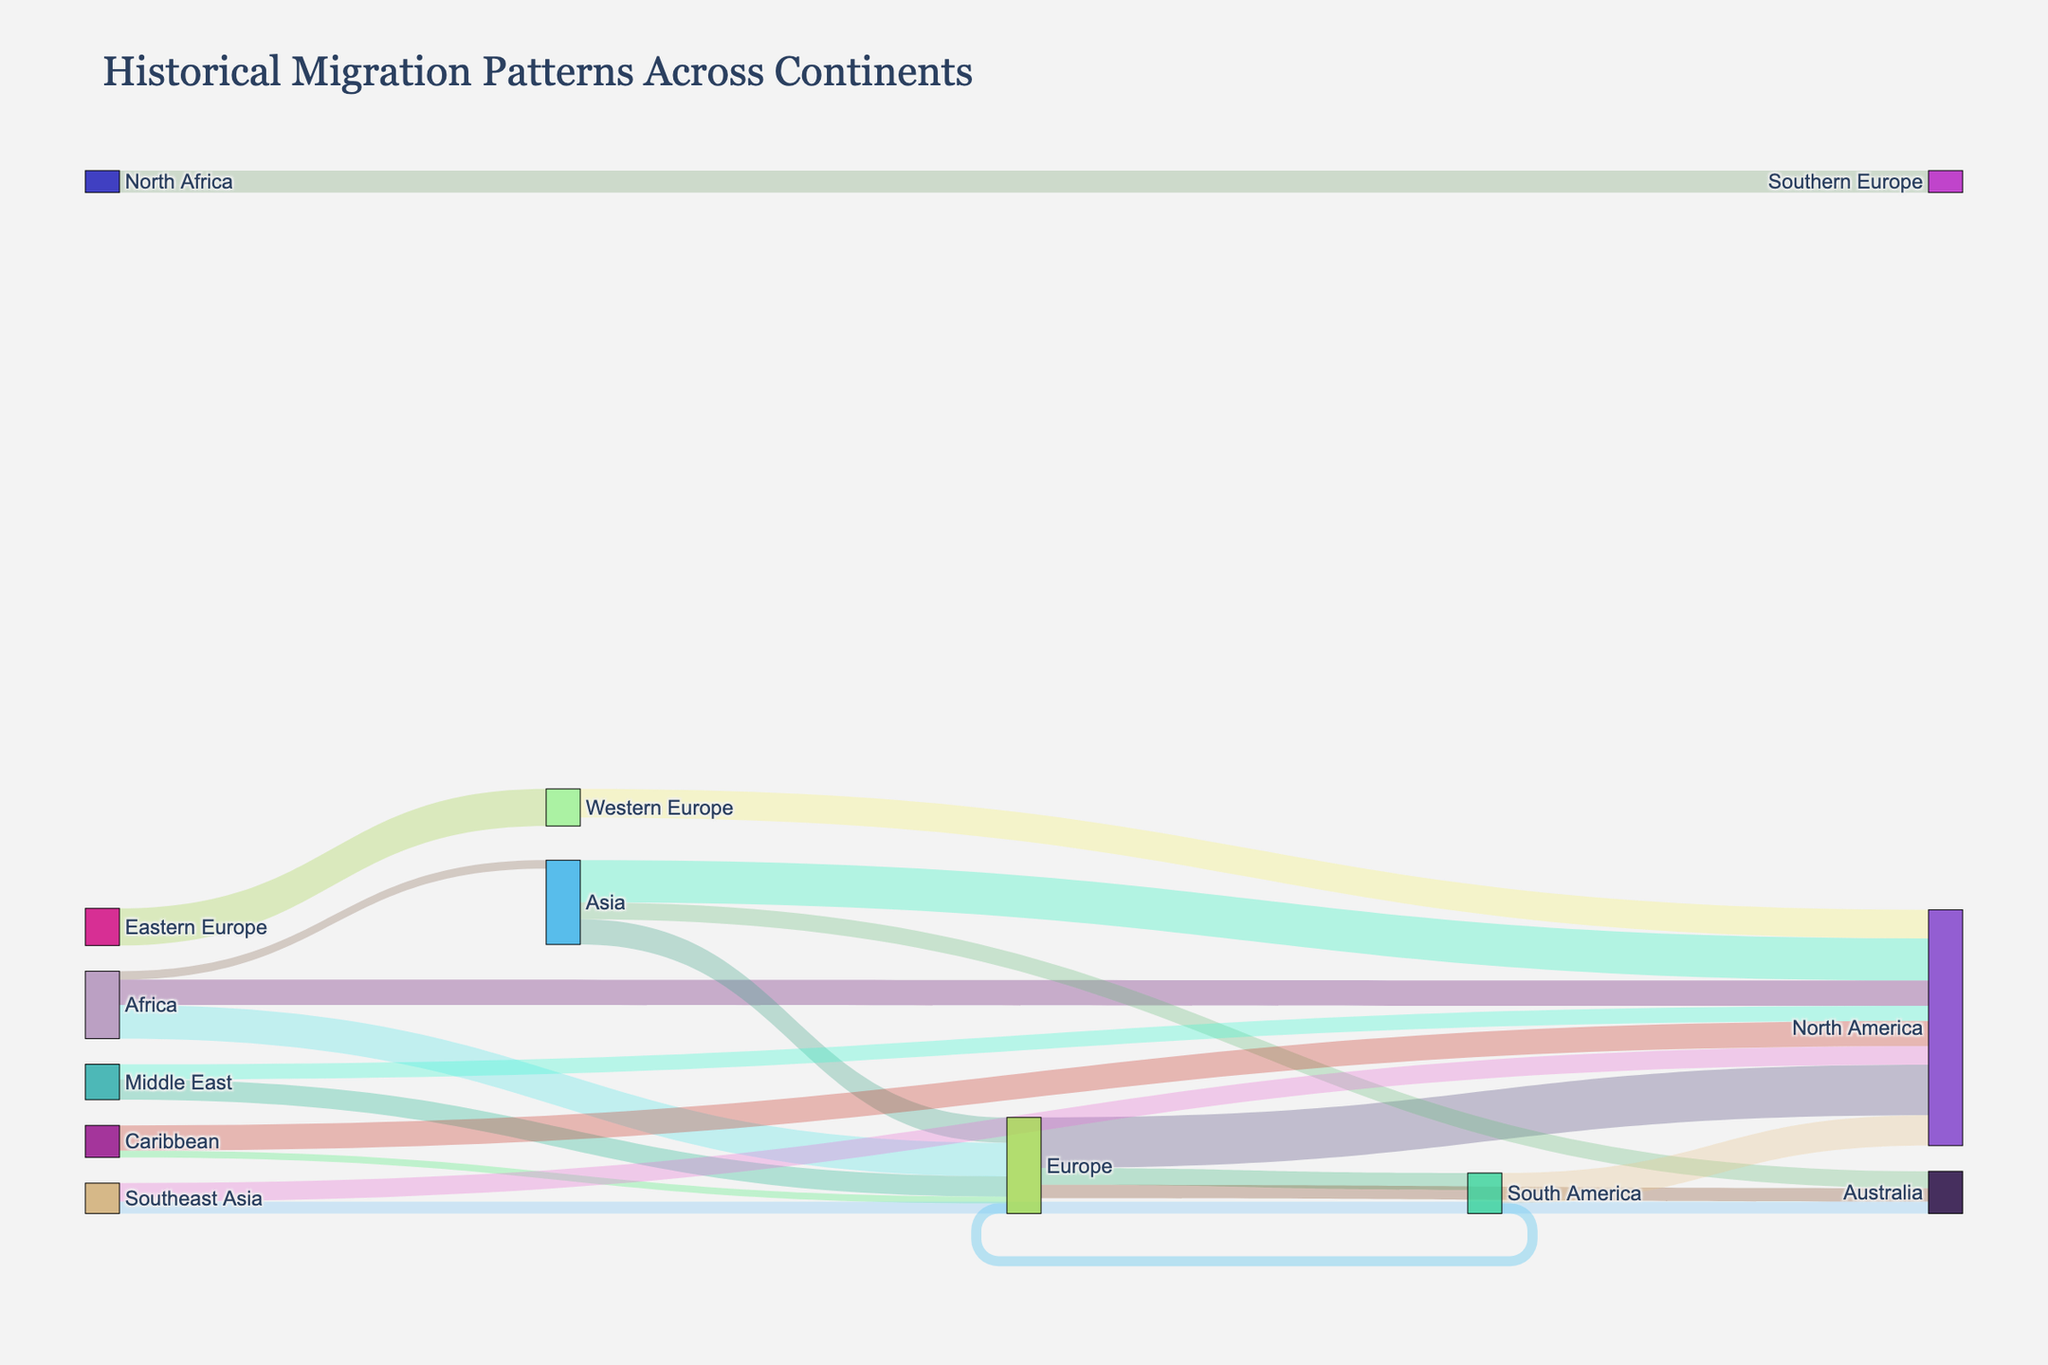What's the title of the figure? The title is usually placed at the top of the figure. In this case, it's directly mentioned in the layout settings of the code.
Answer: Historical Migration Patterns Across Continents Which continent has the largest migration flow to North America? Look for the thickest line flowing into North America and then trace it back to the source continent. Compare the values if necessary.
Answer: Europe How much migration occurred from Africa to Europe and North America combined? Add the values of migration from Africa to Europe and Africa to North America. The values are 2,000,000 and 1,500,000.
Answer: 3,500,000 Which regions are directly connected by migration from the Caribbean? Look at the target nodes connected to the Caribbean source node. Identify the regions.
Answer: North America and Europe Does Europe have more emigration to North America or South America? Refer to the thickness of the connecting lines from Europe to North America and South America. Compare their values.
Answer: North America What is the total migration flow into Australia? Sum the values of all migration flows into Australia: from Europe, Asia, and Southeast Asia. The values are 800,000, 1,000,000, and 700,000.
Answer: 2,500,000 Compare the migration flow from the Middle East to Europe with that from Asia to Europe. Which is greater? Check the values of migration from the Middle East to Europe and Asia to Europe. Compare their values.
Answer: Middle East to Europe What percentage of African migration went to Asia? Calculate the fraction of African migration to Asia relative to the total migration from Africa, then convert to a percentage. Total migration from Africa is 2,000,000 + 1,500,000 + 500,000 = 4,000,000.
Answer: 12.5% How many regions did North America receive significant migration flows from? Count the number of distinct sources that have migration flows into North America.
Answer: 7 Identify a reciprocal migration flow between two regions shown in the diagram. Look for pairs of regions that have migration flows going both ways. Identifying such pairs requires checking both directions.
Answer: Eastern Europe and Western Europe 